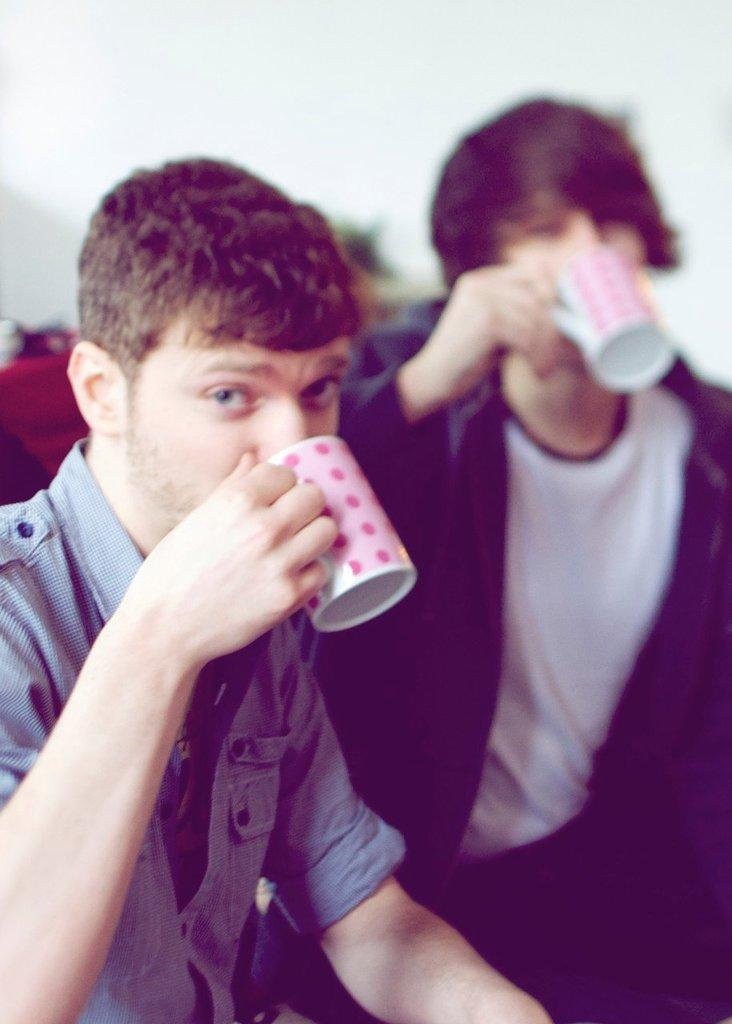How many people are in the image? There are two persons in the image. What are the persons holding in the image? The persons are holding cups. What are the persons doing with the cups? The persons are drinking from the cups. What can be seen in the background of the image? There is a plain wall in the background of the image. Where is the kettle located in the image? There is no kettle present in the image. What type of power source is used by the dolls in the image? There are no dolls present in the image, so there is no power source for them. 